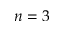Convert formula to latex. <formula><loc_0><loc_0><loc_500><loc_500>n = 3</formula> 